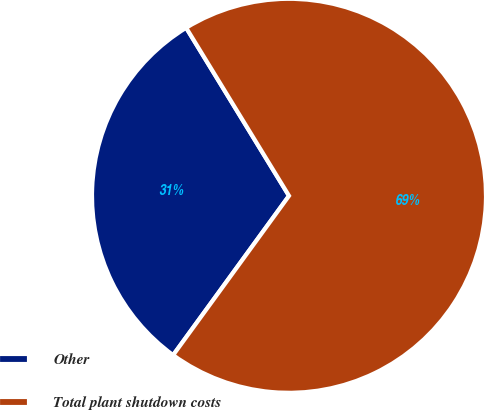<chart> <loc_0><loc_0><loc_500><loc_500><pie_chart><fcel>Other<fcel>Total plant shutdown costs<nl><fcel>31.25%<fcel>68.75%<nl></chart> 